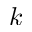<formula> <loc_0><loc_0><loc_500><loc_500>k</formula> 